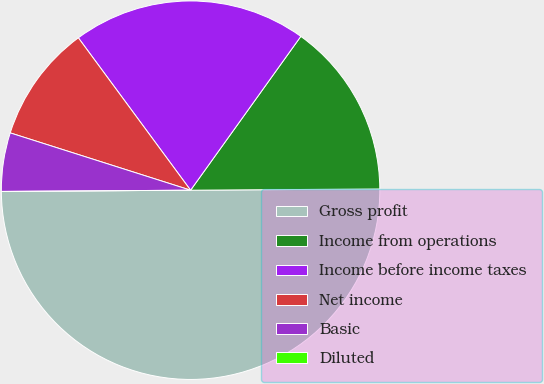Convert chart to OTSL. <chart><loc_0><loc_0><loc_500><loc_500><pie_chart><fcel>Gross profit<fcel>Income from operations<fcel>Income before income taxes<fcel>Net income<fcel>Basic<fcel>Diluted<nl><fcel>50.0%<fcel>15.0%<fcel>20.0%<fcel>10.0%<fcel>5.0%<fcel>0.0%<nl></chart> 